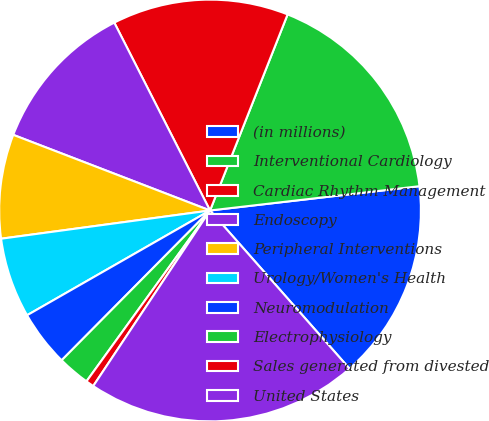<chart> <loc_0><loc_0><loc_500><loc_500><pie_chart><fcel>(in millions)<fcel>Interventional Cardiology<fcel>Cardiac Rhythm Management<fcel>Endoscopy<fcel>Peripheral Interventions<fcel>Urology/Women's Health<fcel>Neuromodulation<fcel>Electrophysiology<fcel>Sales generated from divested<fcel>United States<nl><fcel>15.34%<fcel>17.17%<fcel>13.5%<fcel>11.66%<fcel>7.98%<fcel>6.14%<fcel>4.3%<fcel>2.46%<fcel>0.62%<fcel>20.85%<nl></chart> 